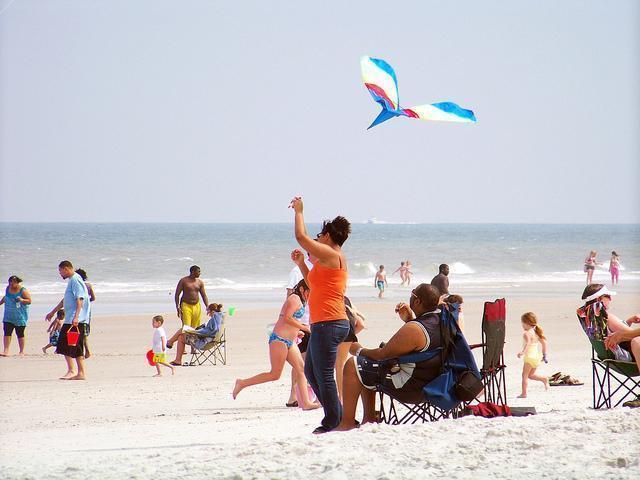What is missing in the picture that is typical at beaches?
Make your selection from the four choices given to correctly answer the question.
Options: Umbrellas, beach towels, fording chairs, buckets. Umbrellas. 